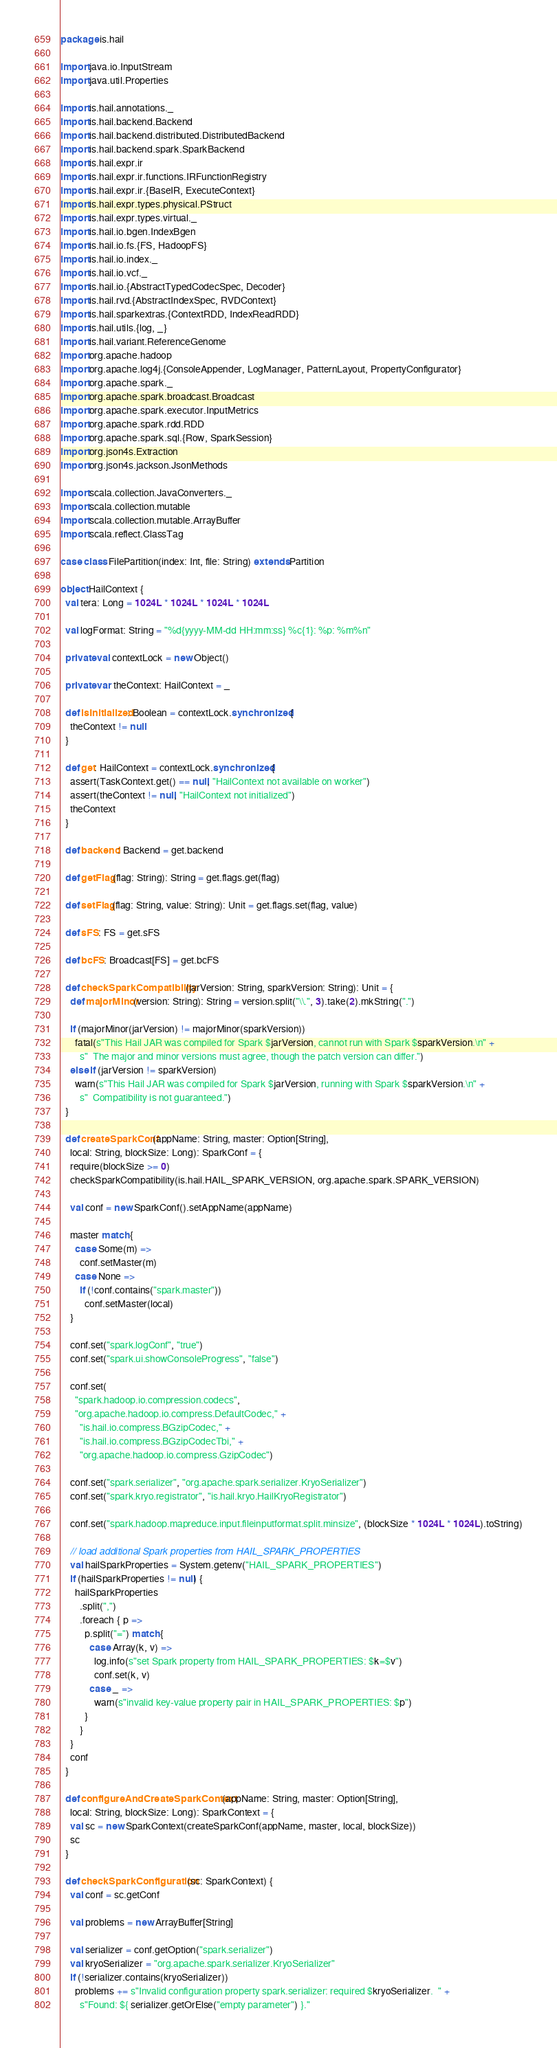Convert code to text. <code><loc_0><loc_0><loc_500><loc_500><_Scala_>package is.hail

import java.io.InputStream
import java.util.Properties

import is.hail.annotations._
import is.hail.backend.Backend
import is.hail.backend.distributed.DistributedBackend
import is.hail.backend.spark.SparkBackend
import is.hail.expr.ir
import is.hail.expr.ir.functions.IRFunctionRegistry
import is.hail.expr.ir.{BaseIR, ExecuteContext}
import is.hail.expr.types.physical.PStruct
import is.hail.expr.types.virtual._
import is.hail.io.bgen.IndexBgen
import is.hail.io.fs.{FS, HadoopFS}
import is.hail.io.index._
import is.hail.io.vcf._
import is.hail.io.{AbstractTypedCodecSpec, Decoder}
import is.hail.rvd.{AbstractIndexSpec, RVDContext}
import is.hail.sparkextras.{ContextRDD, IndexReadRDD}
import is.hail.utils.{log, _}
import is.hail.variant.ReferenceGenome
import org.apache.hadoop
import org.apache.log4j.{ConsoleAppender, LogManager, PatternLayout, PropertyConfigurator}
import org.apache.spark._
import org.apache.spark.broadcast.Broadcast
import org.apache.spark.executor.InputMetrics
import org.apache.spark.rdd.RDD
import org.apache.spark.sql.{Row, SparkSession}
import org.json4s.Extraction
import org.json4s.jackson.JsonMethods

import scala.collection.JavaConverters._
import scala.collection.mutable
import scala.collection.mutable.ArrayBuffer
import scala.reflect.ClassTag

case class FilePartition(index: Int, file: String) extends Partition

object HailContext {
  val tera: Long = 1024L * 1024L * 1024L * 1024L

  val logFormat: String = "%d{yyyy-MM-dd HH:mm:ss} %c{1}: %p: %m%n"

  private val contextLock = new Object()

  private var theContext: HailContext = _

  def isInitialized: Boolean = contextLock.synchronized {
    theContext != null
  }

  def get: HailContext = contextLock.synchronized {
    assert(TaskContext.get() == null, "HailContext not available on worker")
    assert(theContext != null, "HailContext not initialized")
    theContext
  }

  def backend: Backend = get.backend

  def getFlag(flag: String): String = get.flags.get(flag)

  def setFlag(flag: String, value: String): Unit = get.flags.set(flag, value)

  def sFS: FS = get.sFS

  def bcFS: Broadcast[FS] = get.bcFS

  def checkSparkCompatibility(jarVersion: String, sparkVersion: String): Unit = {
    def majorMinor(version: String): String = version.split("\\.", 3).take(2).mkString(".")

    if (majorMinor(jarVersion) != majorMinor(sparkVersion))
      fatal(s"This Hail JAR was compiled for Spark $jarVersion, cannot run with Spark $sparkVersion.\n" +
        s"  The major and minor versions must agree, though the patch version can differ.")
    else if (jarVersion != sparkVersion)
      warn(s"This Hail JAR was compiled for Spark $jarVersion, running with Spark $sparkVersion.\n" +
        s"  Compatibility is not guaranteed.")
  }

  def createSparkConf(appName: String, master: Option[String],
    local: String, blockSize: Long): SparkConf = {
    require(blockSize >= 0)
    checkSparkCompatibility(is.hail.HAIL_SPARK_VERSION, org.apache.spark.SPARK_VERSION)

    val conf = new SparkConf().setAppName(appName)

    master match {
      case Some(m) =>
        conf.setMaster(m)
      case None =>
        if (!conf.contains("spark.master"))
          conf.setMaster(local)
    }

    conf.set("spark.logConf", "true")
    conf.set("spark.ui.showConsoleProgress", "false")

    conf.set(
      "spark.hadoop.io.compression.codecs",
      "org.apache.hadoop.io.compress.DefaultCodec," +
        "is.hail.io.compress.BGzipCodec," +
        "is.hail.io.compress.BGzipCodecTbi," +
        "org.apache.hadoop.io.compress.GzipCodec")

    conf.set("spark.serializer", "org.apache.spark.serializer.KryoSerializer")
    conf.set("spark.kryo.registrator", "is.hail.kryo.HailKryoRegistrator")

    conf.set("spark.hadoop.mapreduce.input.fileinputformat.split.minsize", (blockSize * 1024L * 1024L).toString)

    // load additional Spark properties from HAIL_SPARK_PROPERTIES
    val hailSparkProperties = System.getenv("HAIL_SPARK_PROPERTIES")
    if (hailSparkProperties != null) {
      hailSparkProperties
        .split(",")
        .foreach { p =>
          p.split("=") match {
            case Array(k, v) =>
              log.info(s"set Spark property from HAIL_SPARK_PROPERTIES: $k=$v")
              conf.set(k, v)
            case _ =>
              warn(s"invalid key-value property pair in HAIL_SPARK_PROPERTIES: $p")
          }
        }
    }
    conf
  }

  def configureAndCreateSparkContext(appName: String, master: Option[String],
    local: String, blockSize: Long): SparkContext = {
    val sc = new SparkContext(createSparkConf(appName, master, local, blockSize))
    sc
  }

  def checkSparkConfiguration(sc: SparkContext) {
    val conf = sc.getConf

    val problems = new ArrayBuffer[String]

    val serializer = conf.getOption("spark.serializer")
    val kryoSerializer = "org.apache.spark.serializer.KryoSerializer"
    if (!serializer.contains(kryoSerializer))
      problems += s"Invalid configuration property spark.serializer: required $kryoSerializer.  " +
        s"Found: ${ serializer.getOrElse("empty parameter") }."
</code> 